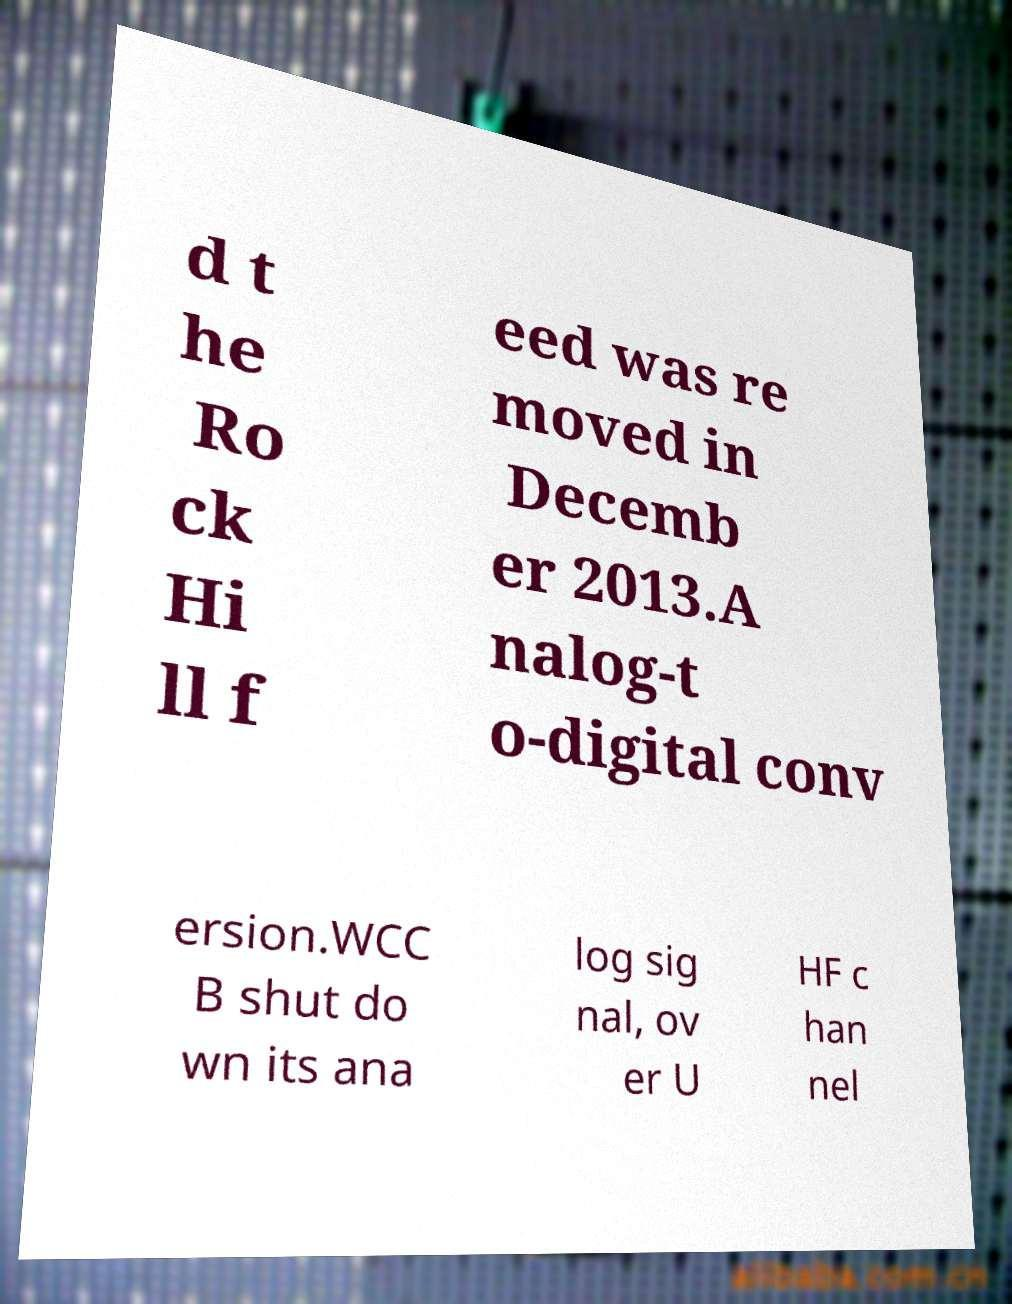Can you accurately transcribe the text from the provided image for me? d t he Ro ck Hi ll f eed was re moved in Decemb er 2013.A nalog-t o-digital conv ersion.WCC B shut do wn its ana log sig nal, ov er U HF c han nel 